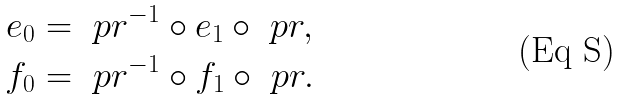Convert formula to latex. <formula><loc_0><loc_0><loc_500><loc_500>e _ { 0 } & = \ p r ^ { - 1 } \circ e _ { 1 } \circ \ p r , \\ f _ { 0 } & = \ p r ^ { - 1 } \circ f _ { 1 } \circ \ p r .</formula> 